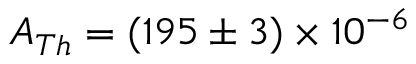Convert formula to latex. <formula><loc_0><loc_0><loc_500><loc_500>A _ { T h } = ( 1 9 5 \pm 3 ) \times 1 0 ^ { - 6 }</formula> 